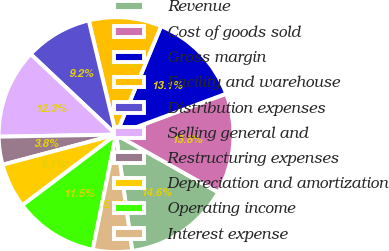Convert chart to OTSL. <chart><loc_0><loc_0><loc_500><loc_500><pie_chart><fcel>Revenue<fcel>Cost of goods sold<fcel>Gross margin<fcel>Facility and warehouse<fcel>Distribution expenses<fcel>Selling general and<fcel>Restructuring expenses<fcel>Depreciation and amortization<fcel>Operating income<fcel>Interest expense<nl><fcel>14.62%<fcel>13.85%<fcel>13.08%<fcel>10.0%<fcel>9.23%<fcel>12.31%<fcel>3.85%<fcel>6.15%<fcel>11.54%<fcel>5.38%<nl></chart> 